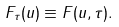Convert formula to latex. <formula><loc_0><loc_0><loc_500><loc_500>F _ { \tau } ( u ) \equiv F ( u , \tau ) .</formula> 